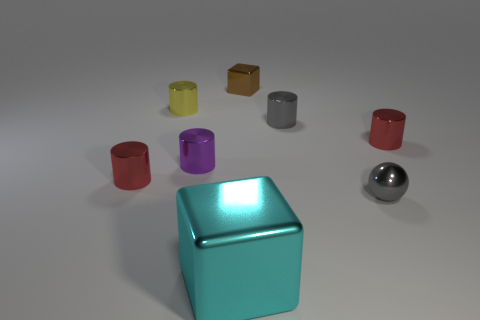Subtract all purple cylinders. How many cylinders are left? 4 Subtract all tiny purple metallic cylinders. How many cylinders are left? 4 Subtract all green cylinders. Subtract all brown cubes. How many cylinders are left? 5 Add 1 big green balls. How many objects exist? 9 Subtract all cylinders. How many objects are left? 3 Add 7 cyan blocks. How many cyan blocks exist? 8 Subtract 0 green balls. How many objects are left? 8 Subtract all gray objects. Subtract all large cyan cubes. How many objects are left? 5 Add 2 small metal spheres. How many small metal spheres are left? 3 